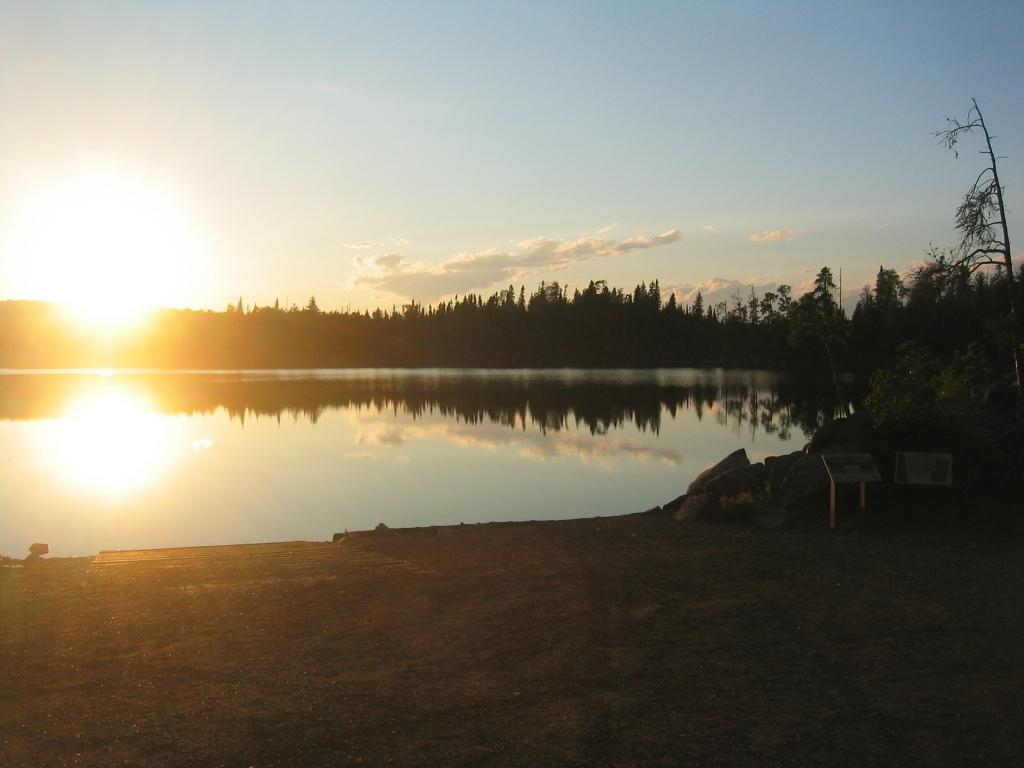What type of body of water is present in the image? There is a lake in the image. What other natural elements can be seen in the image? There are trees in the image. What is visible in the background of the image? The sky is visible in the image. What type of terrain is in front of the lake? There are rocks in front of the lake. What structures are present in front of the lake? There are poles with boards in front of the lake. How many cows are grazing near the lake in the image? There are no cows present in the image. What type of print can be seen on the boards attached to the poles? There is no print visible on the boards attached to the poles in the image. 